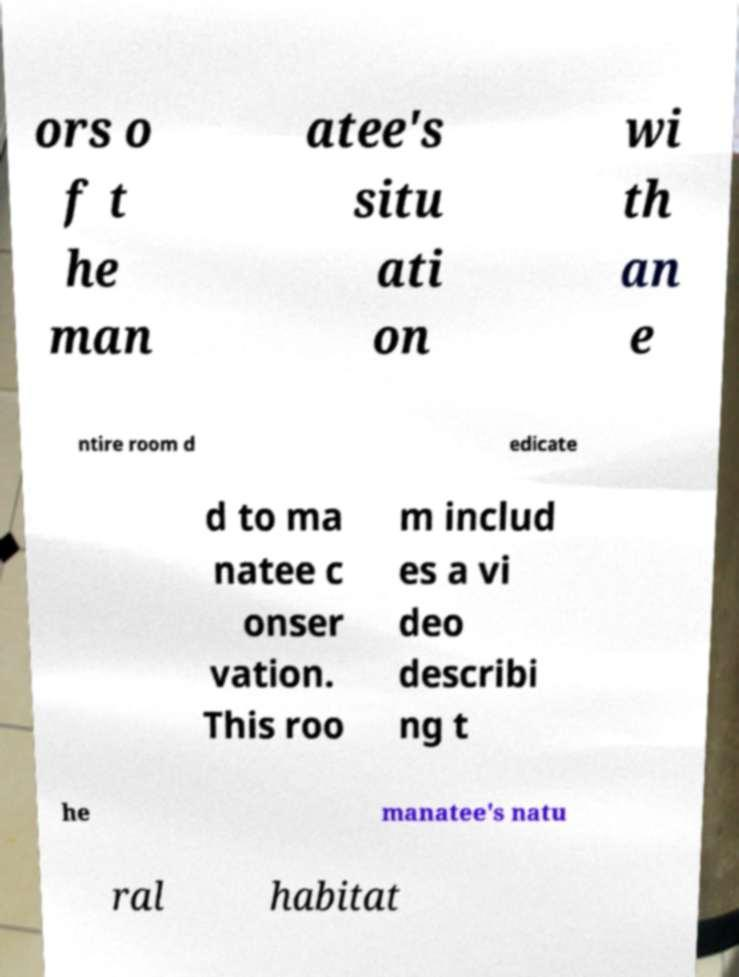Can you read and provide the text displayed in the image?This photo seems to have some interesting text. Can you extract and type it out for me? ors o f t he man atee's situ ati on wi th an e ntire room d edicate d to ma natee c onser vation. This roo m includ es a vi deo describi ng t he manatee's natu ral habitat 